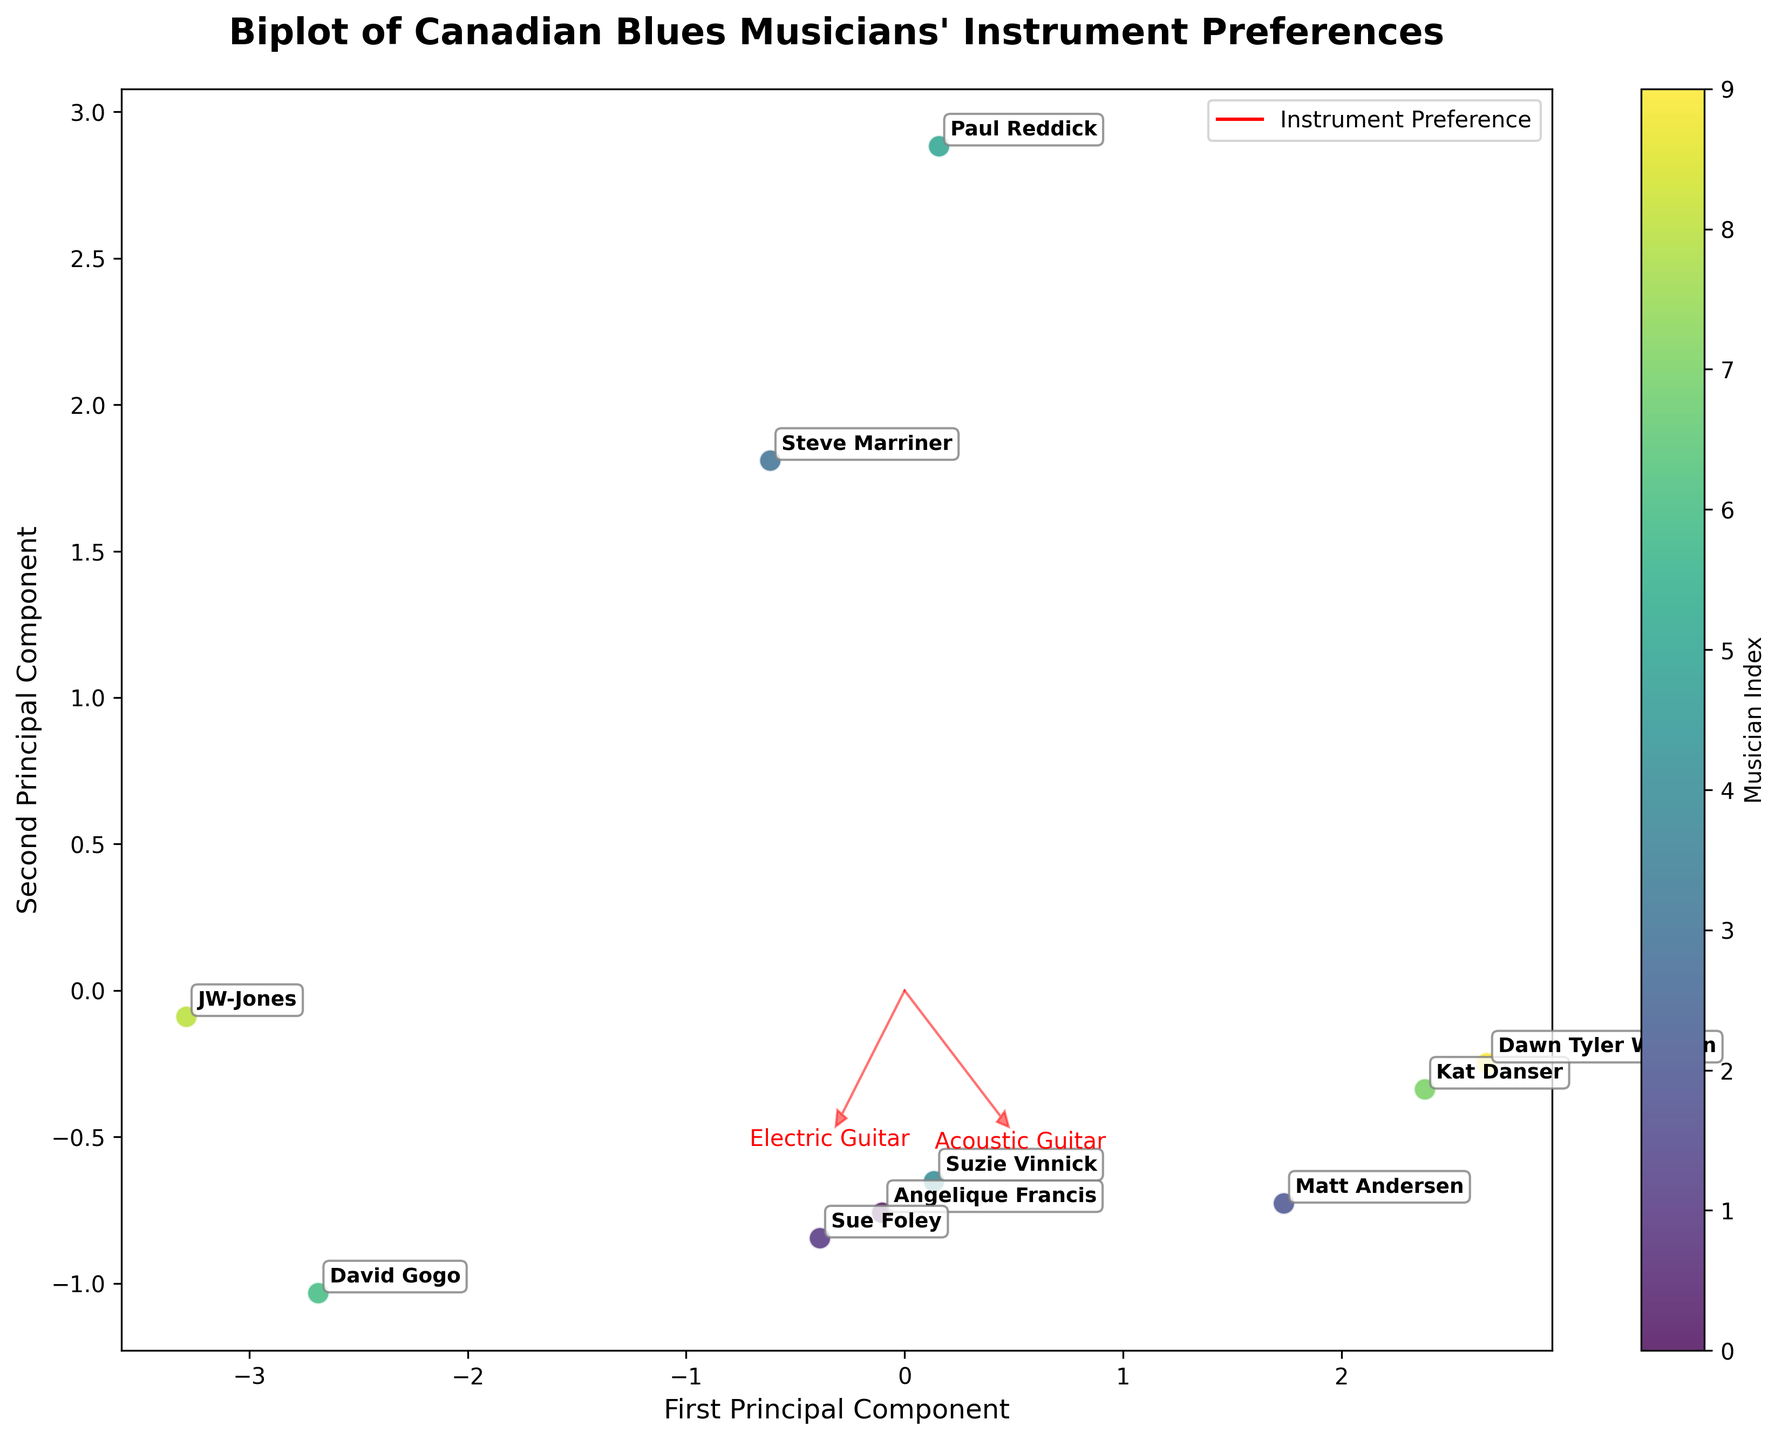How many musicians are plotted in the figure? Count the number of data points (each annotated with a musician's name) in the plot.
Answer: 10 Which musician has the highest value for Electric Guitar preference? Locate the Electric Guitar vector and find the musician closest to it.
Answer: JW-Jones Which musician has the lowest preference for the Harmonica? Locate the Harmonica vector and find the musician farthest from it along the same direction.
Answer: Matt Andersen How are the preferences for Acoustic Guitar and Electric Bass related? Observe the directions of the Acoustic Guitar and Electric Bass vectors; if the vectors are in opposite directions, they are negatively correlated.
Answer: Negatively correlated Which instruments seem to be correlated? Check the vectors that point in similar directions; for example, if Acoustic Guitar and Piano vectors point in similar directions, they are positively correlated. Explain which instruments have vectors pointing in similar directions.
Answer: Acoustic Guitar and Piano What is the position of Angelique Francis relative to the Acoustic Guitar and Harmonica vectors? Locate Angelique Francis using her annotated name and see her position relative to the direction of the Acoustic Guitar and Harmonica vectors.
Answer: Closer to Acoustic Guitar than Harmonica How does Matt Andersen's preference profile compare to Steve Marriner's? Compare the positions of Matt Andersen and Steve Marriner in the plot, referring to their distances from various instrument vectors. Matt Andersen is close to Acoustic Guitar and Electric Guitar, but far from Harmonica, while Steve Marriner is evenly spread.
Answer: Different, Matt prefers Acoustic Guitar, Marriner prefers Harmonica How spread out are the preferences for the Electric Bass among musicians? Look at how far the data points (musicians) are spread around the Electric Bass vector. The wider the spread, the more variation there is among musicians.
Answer: Moderately spread Which instrument preference most strongly separates Dawn Tyler Watson from Paul Reddick? Locate Dawn Tyler Watson and Paul Reddick on the plot and find the vector that runs between them/most clearly distinguishes their positions in the biplot.
Answer: Piano Which musician seems to have a balanced preference across multiple instruments? Identify a musician who is not extremely close to any single instrument vector or evenly spaced from many vectors. This is the musician who is centrally located relative to the instrument preference vectors.
Answer: Sue Foley 